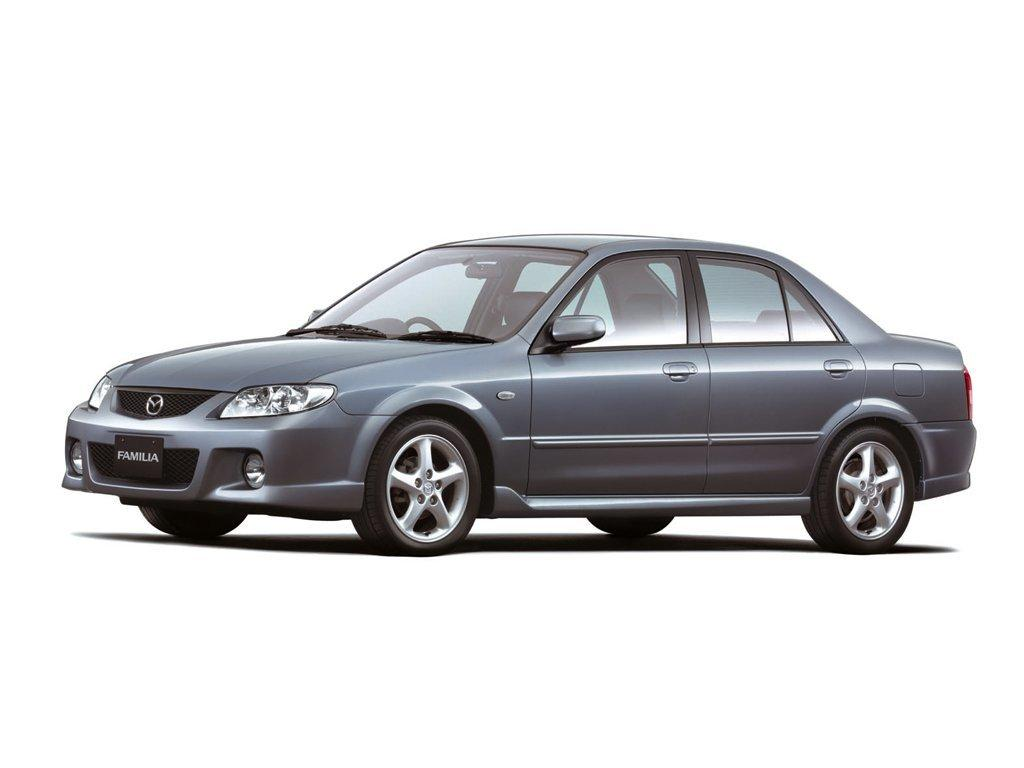What is the main subject of the image? The main subject of the image is a picture of a car. Where is the car located in the image? The car is in the middle of the image. What type of pump is being used by the grandmother in the image? There is no grandmother or pump present in the image; it only features a picture of a car. 